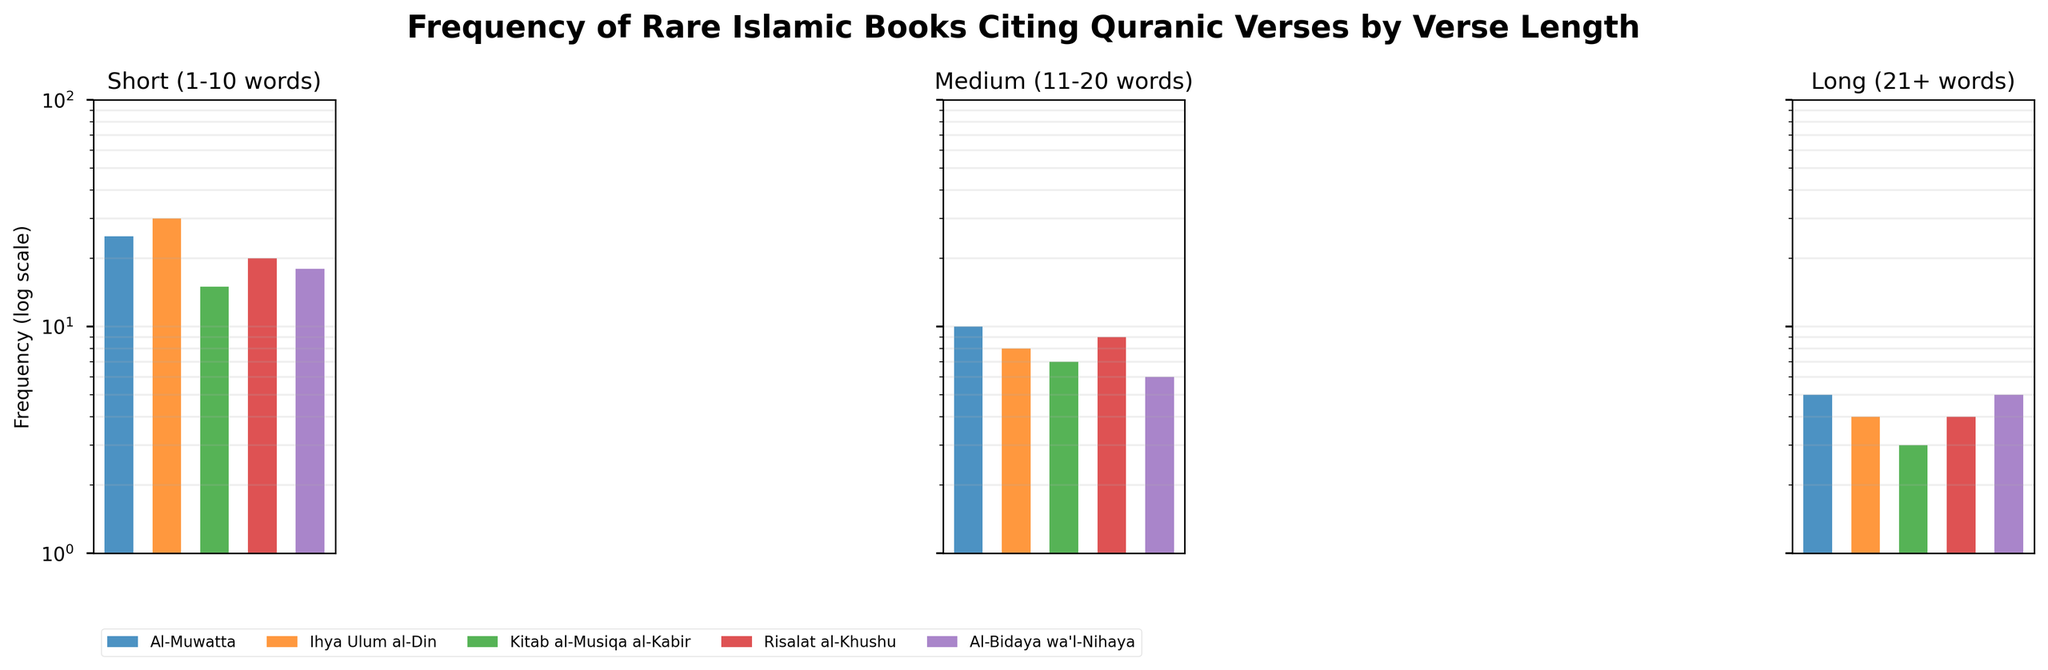What is the title of the figure? The title is generally found at the top of the figure. In this case, the title is "Frequency of Rare Islamic Books Citing Quranic Verses by Verse Length."
Answer: Frequency of Rare Islamic Books Citing Quranic Verses by Verse Length Which verse length category has the highest frequency citation in "Ihya Ulum al-Din"? By looking at the bar heights under the "Short (1-10 words)" subplot, we can observe that "Ihya Ulum al-Din" has the highest frequency citation.
Answer: Short (1-10 words) How many books cite short verses (1-10 words)? Observing the "Short (1-10 words)" subplot, there are 5 different colored bars representing each book ("Al-Muwatta", "Ihya Ulum al-Din", "Kitab al-Musiqa al-Kabir", "Risalat al-Khushu", "Al-Bidaya wa'l-Nihaya").
Answer: 5 What is the frequency of citations for long verses (21+ words) in the book "Kitab al-Musiqa al-Kabir"? Refer to the "Long (21+ words)" subplot and locate the bar for "Kitab al-Musiqa al-Kabir" which shows the frequency citation as 3.
Answer: 3 Which book has the smallest frequency of citing medium length verses (11-20 words)? In the subplot for "Medium (11-20 words)", the bar representing "Al-Bidaya wa'l-Nihaya" has the smallest height indicating a frequency of 6.
Answer: Al-Bidaya wa'l-Nihaya What is the total frequency of verse citations in the book "Al-Muwatta"? Sum the bar heights from "Al-Muwatta" found in each subplot: 25 (short) + 10 (medium) + 5 (long) = 40.
Answer: 40 Compare the frequency of short verses (1-10 words) for "Risalat al-Khushu" and "Al-Bidaya wa'l-Nihaya". Which is higher? Notice the bar heights under "Short (1-10 words)", where "Risalat al-Khushu" has a height of 20 and "Al-Bidaya wa'l-Nihaya" has a height of 18; thus, "Risalat al-Khushu" is higher.
Answer: Risalat al-Khushu Is there any book that did not cite long verses (21+ words)? In the "Long (21+ words)" subplot, each book has a bar above zero, indicating they all cite long verses.
Answer: No What is the combined citation frequency of medium and long verses in the book "Ihya Ulum al-Din"? Sum the heights of bars for "Ihya Ulum al-Din" under the medium and long subplots: 8 (medium) + 4 (long) = 12.
Answer: 12 Which book has the second-highest citation frequency of short verses (1-10 words)? By comparing the bar heights in the "Short (1-10 words)" subplot, "Risalat al-Khushu" has the second-highest frequency citation of 20, after "Ihya Ulum al-Din" with 30.
Answer: Risalat al-Khushu 